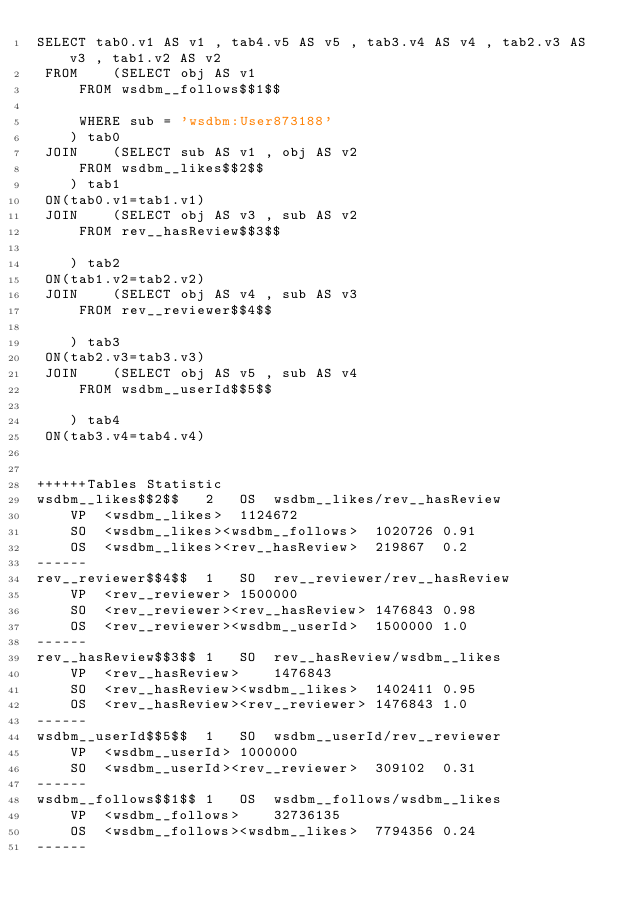<code> <loc_0><loc_0><loc_500><loc_500><_SQL_>SELECT tab0.v1 AS v1 , tab4.v5 AS v5 , tab3.v4 AS v4 , tab2.v3 AS v3 , tab1.v2 AS v2 
 FROM    (SELECT obj AS v1 
	 FROM wsdbm__follows$$1$$
	 
	 WHERE sub = 'wsdbm:User873188'
	) tab0
 JOIN    (SELECT sub AS v1 , obj AS v2 
	 FROM wsdbm__likes$$2$$
	) tab1
 ON(tab0.v1=tab1.v1)
 JOIN    (SELECT obj AS v3 , sub AS v2 
	 FROM rev__hasReview$$3$$
	
	) tab2
 ON(tab1.v2=tab2.v2)
 JOIN    (SELECT obj AS v4 , sub AS v3 
	 FROM rev__reviewer$$4$$
	
	) tab3
 ON(tab2.v3=tab3.v3)
 JOIN    (SELECT obj AS v5 , sub AS v4 
	 FROM wsdbm__userId$$5$$
	
	) tab4
 ON(tab3.v4=tab4.v4)


++++++Tables Statistic
wsdbm__likes$$2$$	2	OS	wsdbm__likes/rev__hasReview
	VP	<wsdbm__likes>	1124672
	SO	<wsdbm__likes><wsdbm__follows>	1020726	0.91
	OS	<wsdbm__likes><rev__hasReview>	219867	0.2
------
rev__reviewer$$4$$	1	SO	rev__reviewer/rev__hasReview
	VP	<rev__reviewer>	1500000
	SO	<rev__reviewer><rev__hasReview>	1476843	0.98
	OS	<rev__reviewer><wsdbm__userId>	1500000	1.0
------
rev__hasReview$$3$$	1	SO	rev__hasReview/wsdbm__likes
	VP	<rev__hasReview>	1476843
	SO	<rev__hasReview><wsdbm__likes>	1402411	0.95
	OS	<rev__hasReview><rev__reviewer>	1476843	1.0
------
wsdbm__userId$$5$$	1	SO	wsdbm__userId/rev__reviewer
	VP	<wsdbm__userId>	1000000
	SO	<wsdbm__userId><rev__reviewer>	309102	0.31
------
wsdbm__follows$$1$$	1	OS	wsdbm__follows/wsdbm__likes
	VP	<wsdbm__follows>	32736135
	OS	<wsdbm__follows><wsdbm__likes>	7794356	0.24
------
</code> 